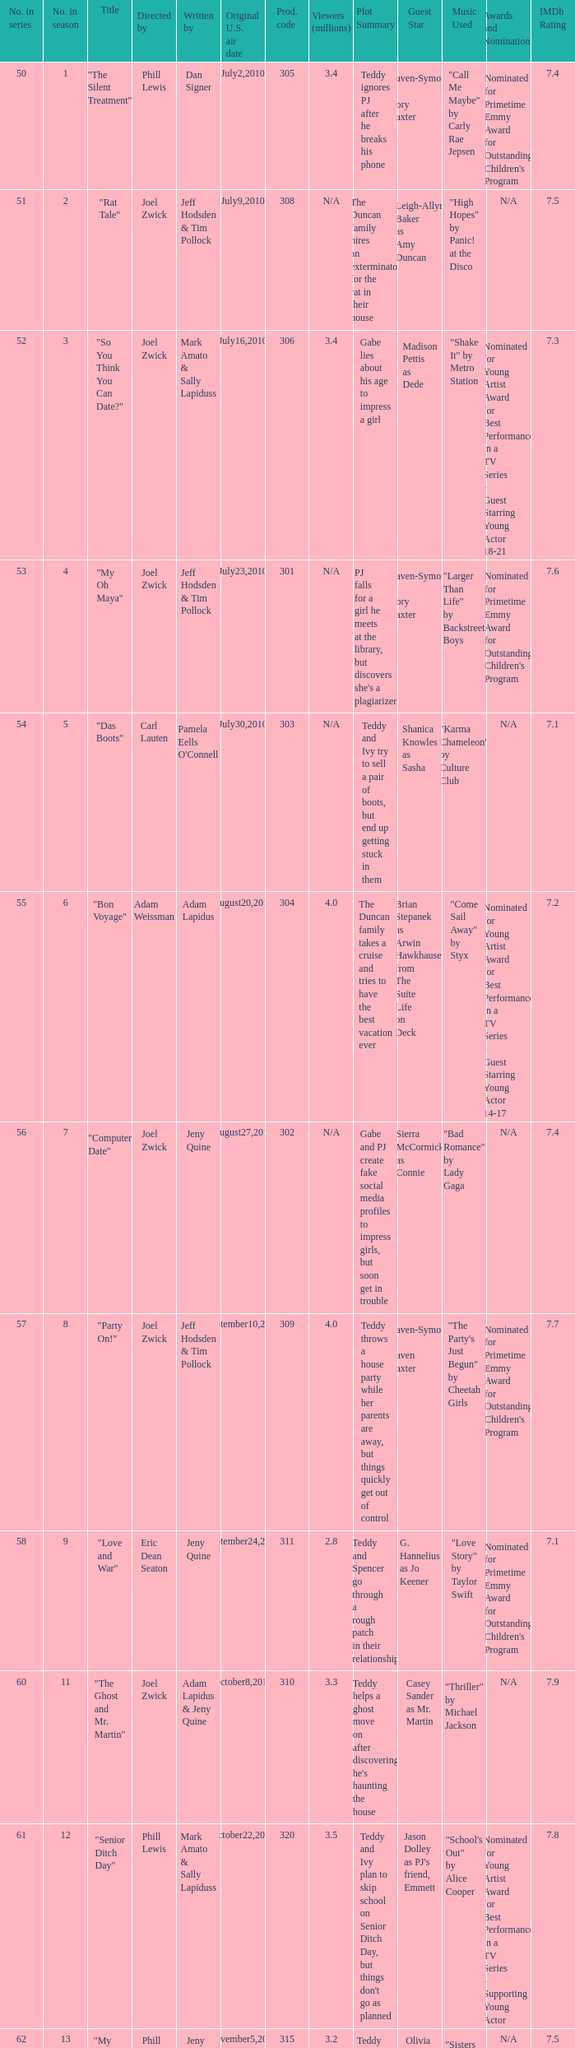What episode number was titled "my oh maya"? 4.0. 